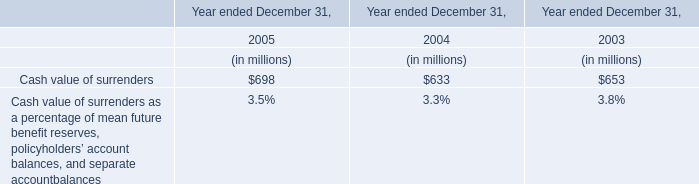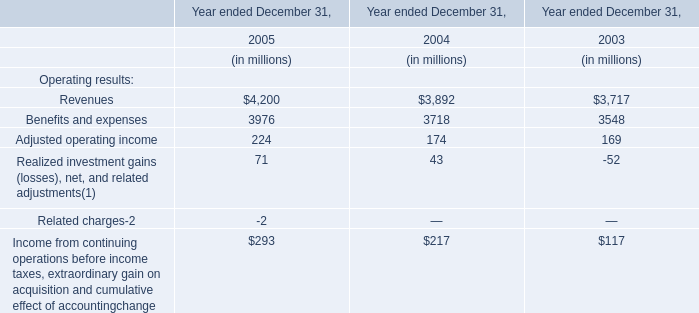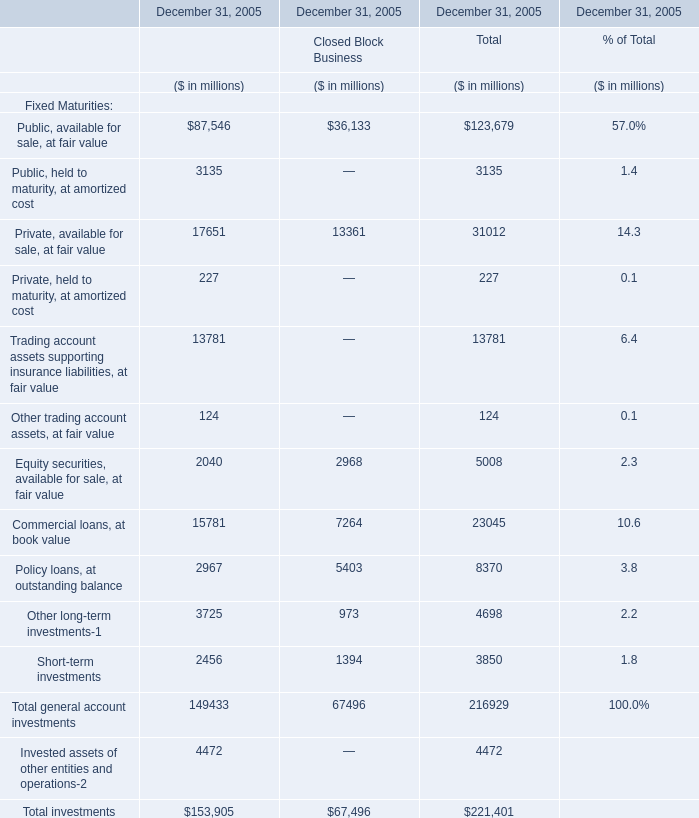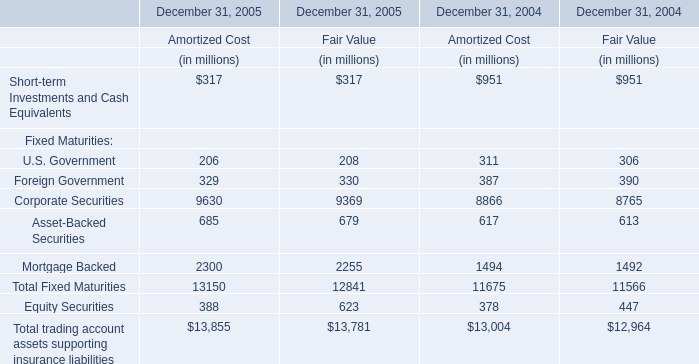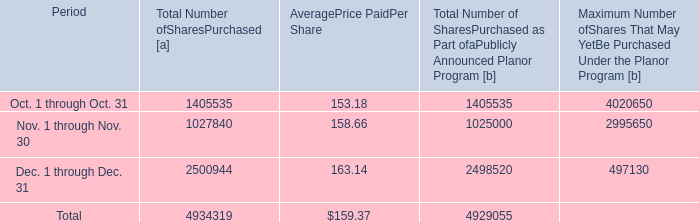what was the percent of the total number of share repurchase in the fourth quarter of 2013 that was attested to upc by employees to pay stock option exercise prices 
Computations: (5264 / 4934319)
Answer: 0.00107. 